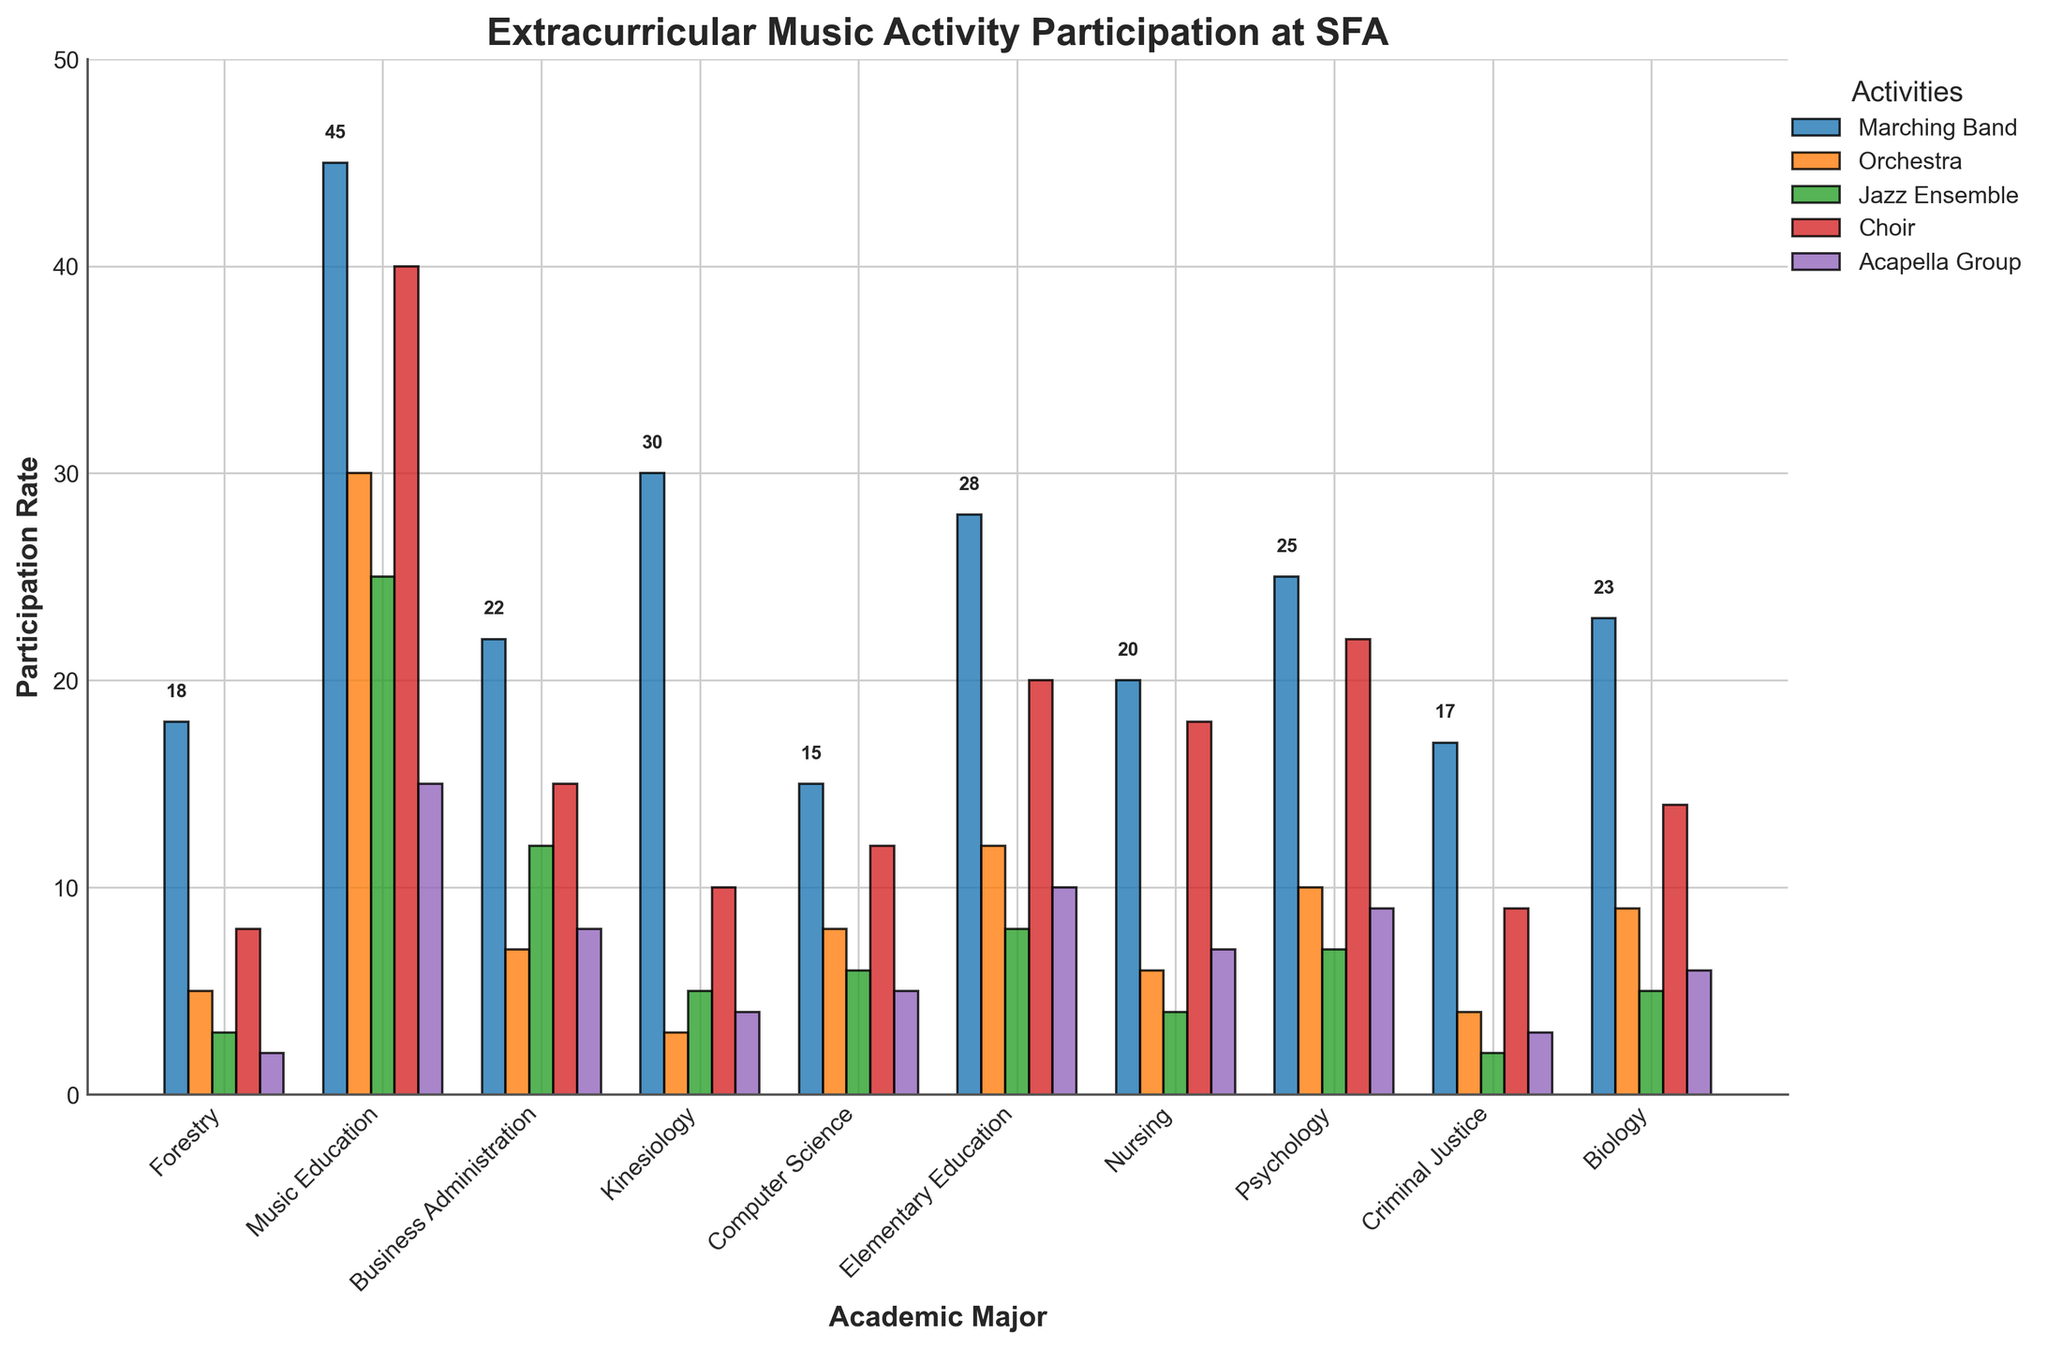What is the most participated extracurricular music activity for Music Education majors? The bar heights for Music Education majors show the highest participation in Marching Band, which is 45.
Answer: Marching Band How does the participation rate in Jazz Ensemble for Business Administration majors compare to that of Computer Science majors? The bar for Jazz Ensemble participation shows 12 for Business Administration and 6 for Computer Science. The rate for Business Administration is double.
Answer: Business Administration has a higher rate Which major has the least participation in Choir? The shortest bar in the Choir category is for Criminal Justice majors with a value of 9.
Answer: Criminal Justice What is the difference in participation rates between Marching Band and Acapella Group for Nursing majors? The bar heights for Nursing majors show a participation rate of 20 for Marching Band and 7 for Acapella Group. The difference is 20 - 7 = 13.
Answer: 13 Which major has the closest participation rates in Orchestra and Jazz Ensemble? The bars for Elementary Education show participation rates of 12 for Orchestra and 8 for Jazz Ensemble, which are relatively close with a difference of 4, the smallest difference among the majors.
Answer: Elementary Education Find the average participation rate for Acapella Group across all majors. Summing the Acapella Group participation rates (2+15+8+4+5+10+7+9+3+6) equals 69. Dividing this sum by the 10 majors yields an average of 69/10.
Answer: 6.9 Which activity shows the most significant range in participation rates across different majors? Observing the difference between the highest and lowest bars for each activity, Marching Band ranges from 45 (maximum) to 15 (minimum), a range of 45-15=30. This is the largest range among all activities.
Answer: Marching Band How many students in total participate in the Orchestra from all majors combined? Summing the Orchestra participation rates from all majors (5+30+7+3+8+12+6+10+4+9) equals 94.
Answer: 94 Identify the major with the highest overall participation rate when summing up all activities. Summing the participation rates for each activity for each major individually reveals Music Education (45+30+25+40+15=155) has the highest total participation rate.
Answer: Music Education What proportion of Kinesiology majors participate in Marching Band compared to the total participation in Jazz Ensemble across all majors? Kinesiology participation in Marching Band is 30; total Jazz Ensemble participation across all majors is (3+25+12+5+6+8+4+7+2+5)=77. Proportion is 30/77.
Answer: 30/77 